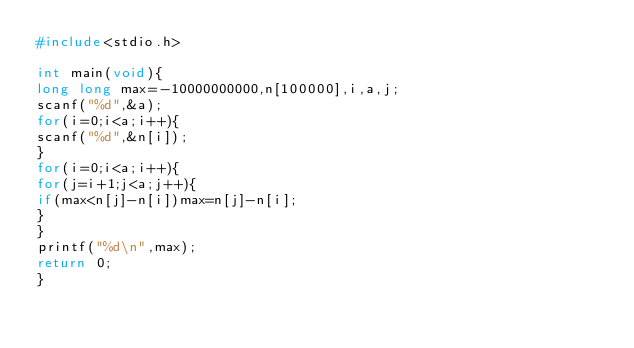Convert code to text. <code><loc_0><loc_0><loc_500><loc_500><_C_>#include<stdio.h>

int main(void){
long long max=-10000000000,n[100000],i,a,j;
scanf("%d",&a);
for(i=0;i<a;i++){
scanf("%d",&n[i]);
}
for(i=0;i<a;i++){
for(j=i+1;j<a;j++){
if(max<n[j]-n[i])max=n[j]-n[i];
}
}
printf("%d\n",max);
return 0;
}</code> 